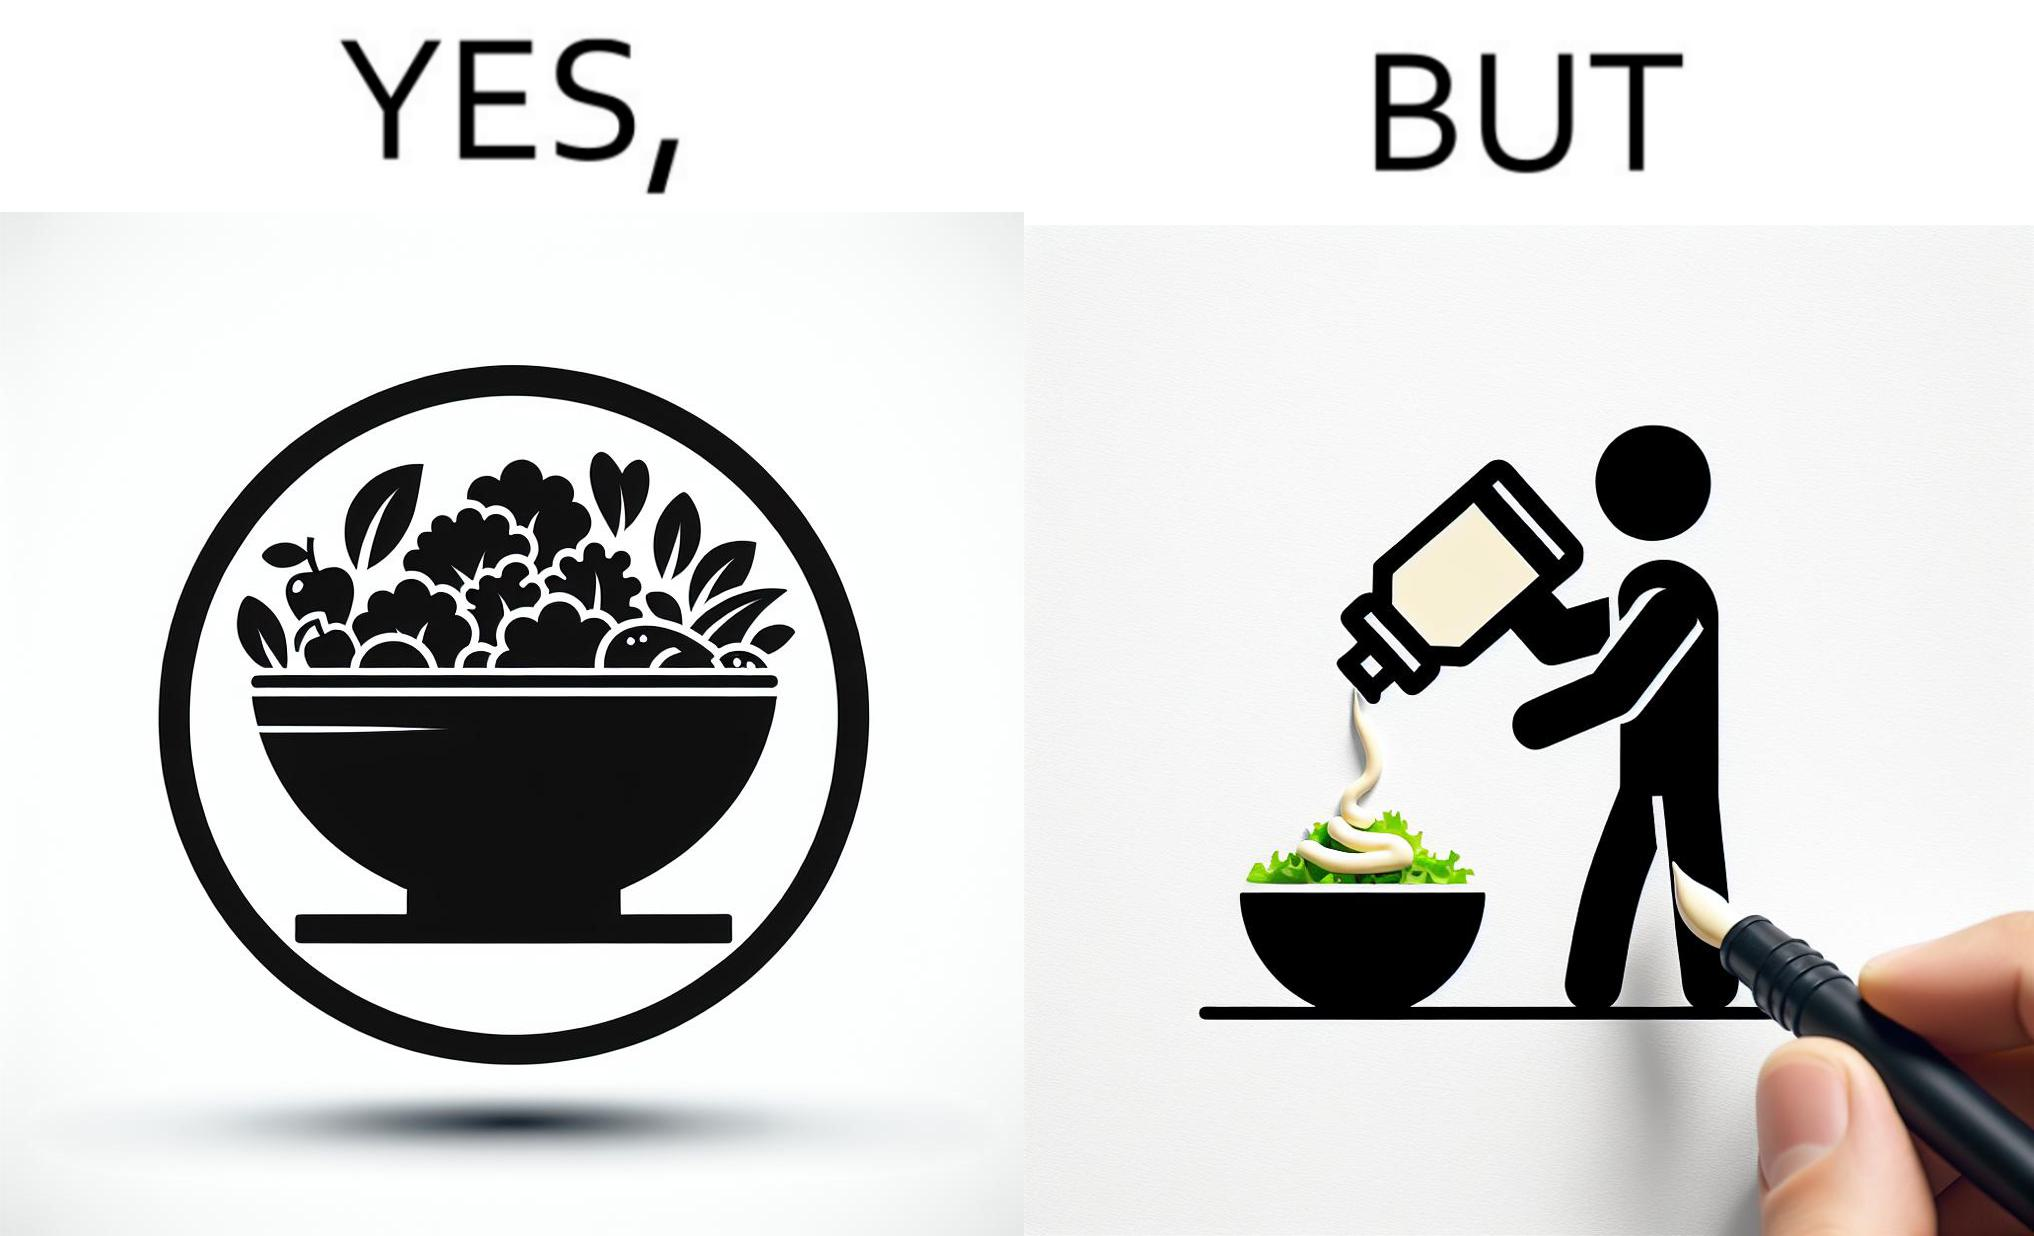Is there satirical content in this image? Yes, this image is satirical. 